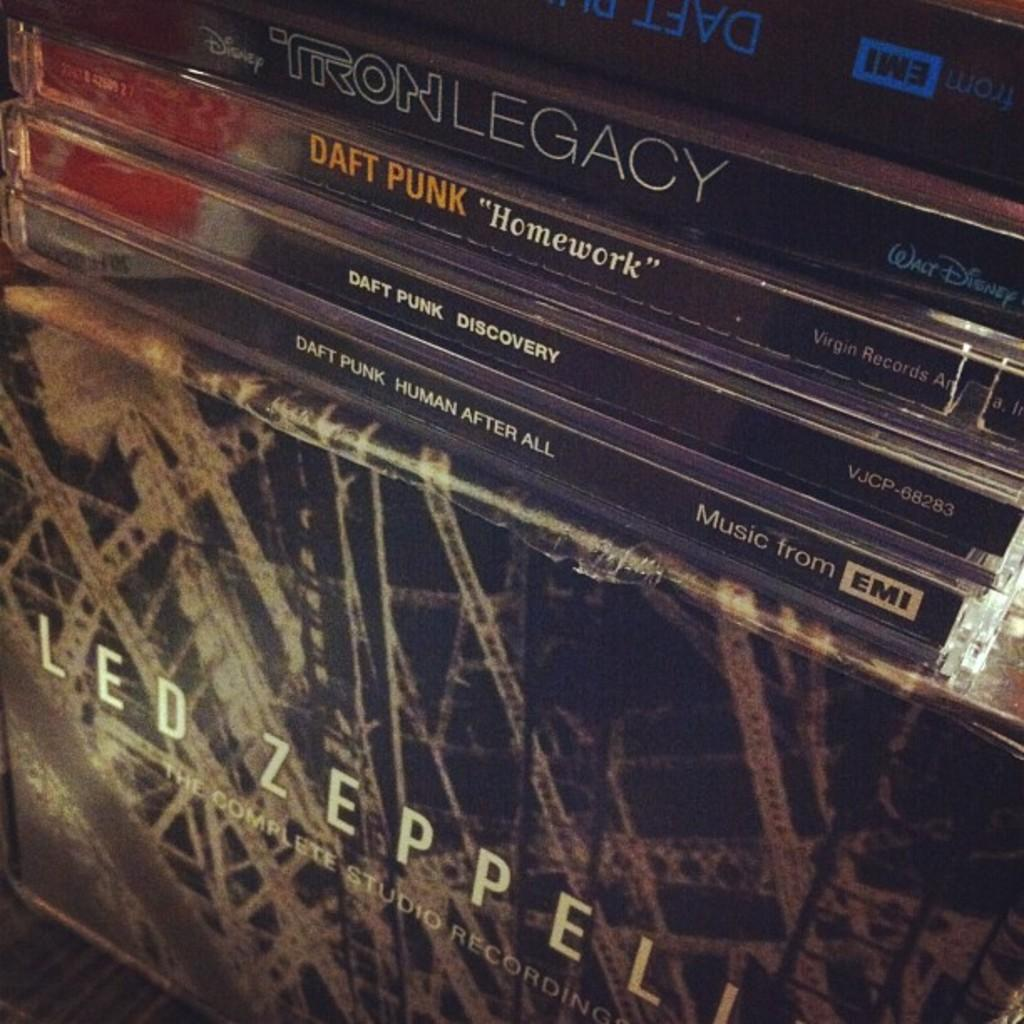<image>
Create a compact narrative representing the image presented. Led zeppelin album as well as Daft Punk's Homework, Discovery, and Human After All albums. 